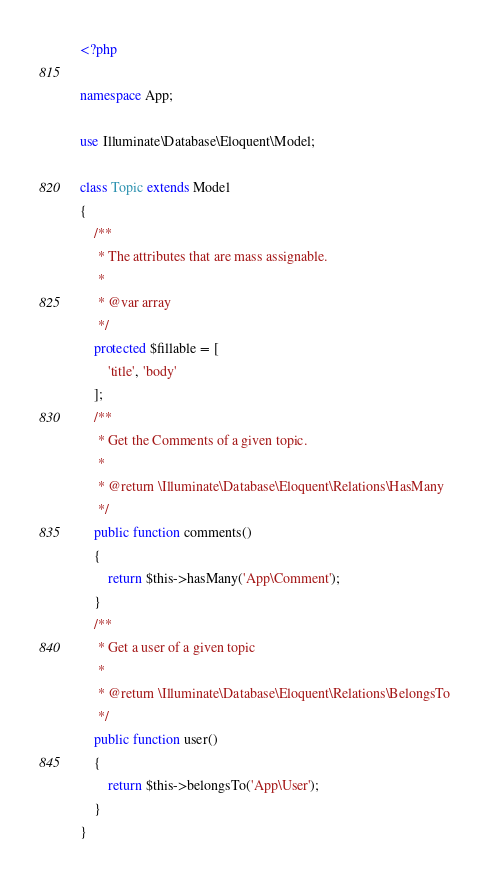Convert code to text. <code><loc_0><loc_0><loc_500><loc_500><_PHP_><?php

namespace App;

use Illuminate\Database\Eloquent\Model;

class Topic extends Model
{
    /**
     * The attributes that are mass assignable.
     *
     * @var array
     */
    protected $fillable = [
        'title', 'body'
    ];
    /**
     * Get the Comments of a given topic.
     *
     * @return \Illuminate\Database\Eloquent\Relations\HasMany
     */
    public function comments()
    {
        return $this->hasMany('App\Comment');
    }
    /**
     * Get a user of a given topic
     *
     * @return \Illuminate\Database\Eloquent\Relations\BelongsTo
     */
    public function user()
    {
        return $this->belongsTo('App\User');
    }
}
</code> 